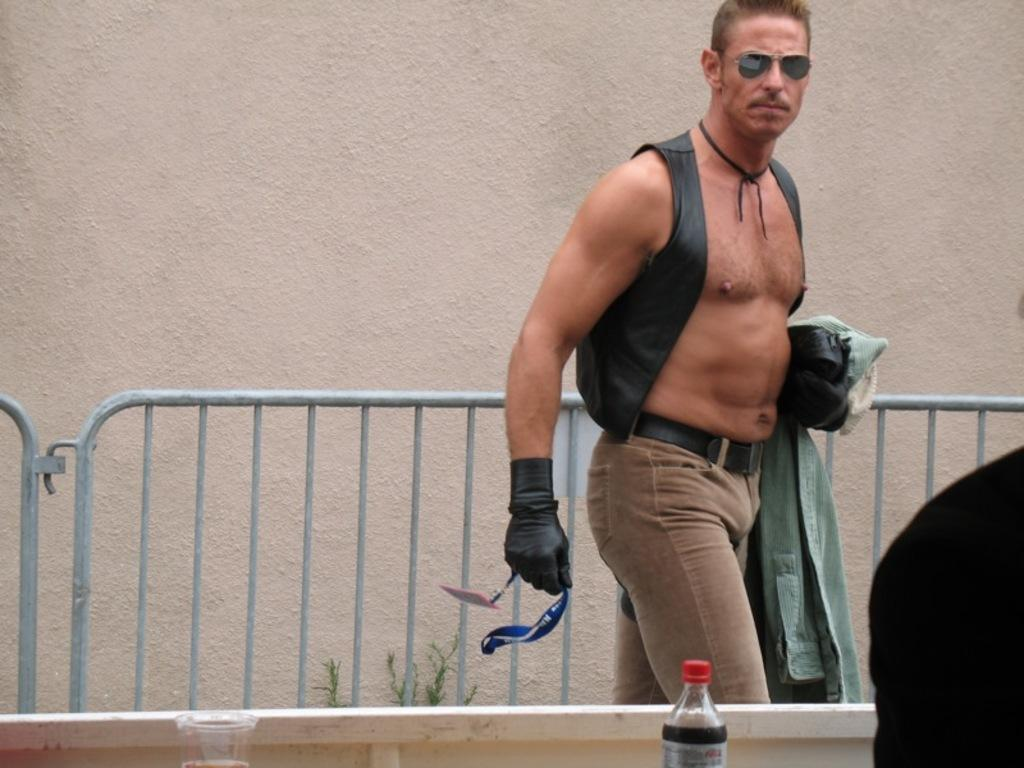What is the main subject of the image? There is a man standing in the image. What can be seen in the background of the image? There is fencing and a wall in the image. What object is visible near the man? There is a soft drink bottle in the image. What type of weather can be seen in the image? The provided facts do not mention any weather-related information, so it cannot be determined from the image. Are there any snails visible in the image? There is no mention of snails in the provided facts, so it cannot be determined if they are present in the image. 